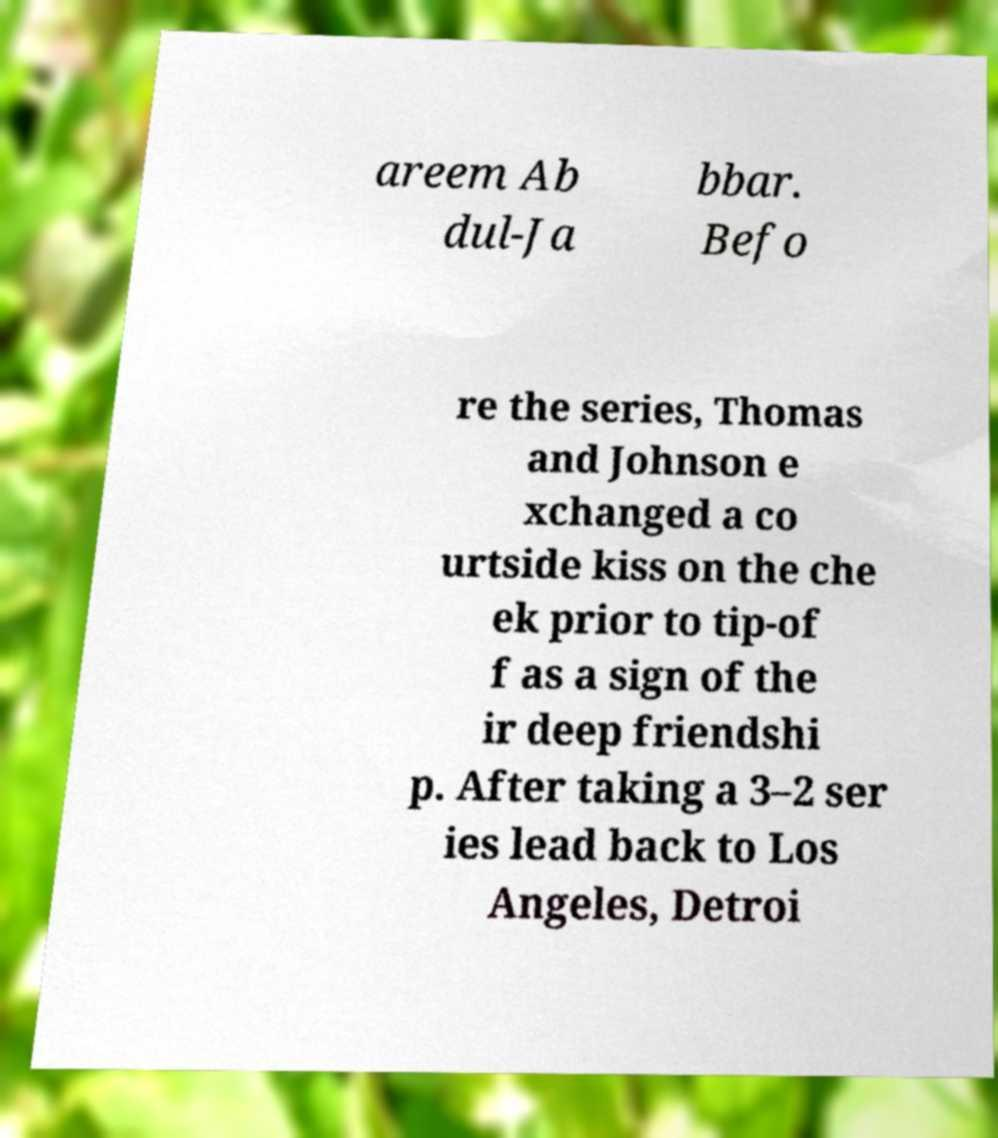Could you extract and type out the text from this image? areem Ab dul-Ja bbar. Befo re the series, Thomas and Johnson e xchanged a co urtside kiss on the che ek prior to tip-of f as a sign of the ir deep friendshi p. After taking a 3–2 ser ies lead back to Los Angeles, Detroi 